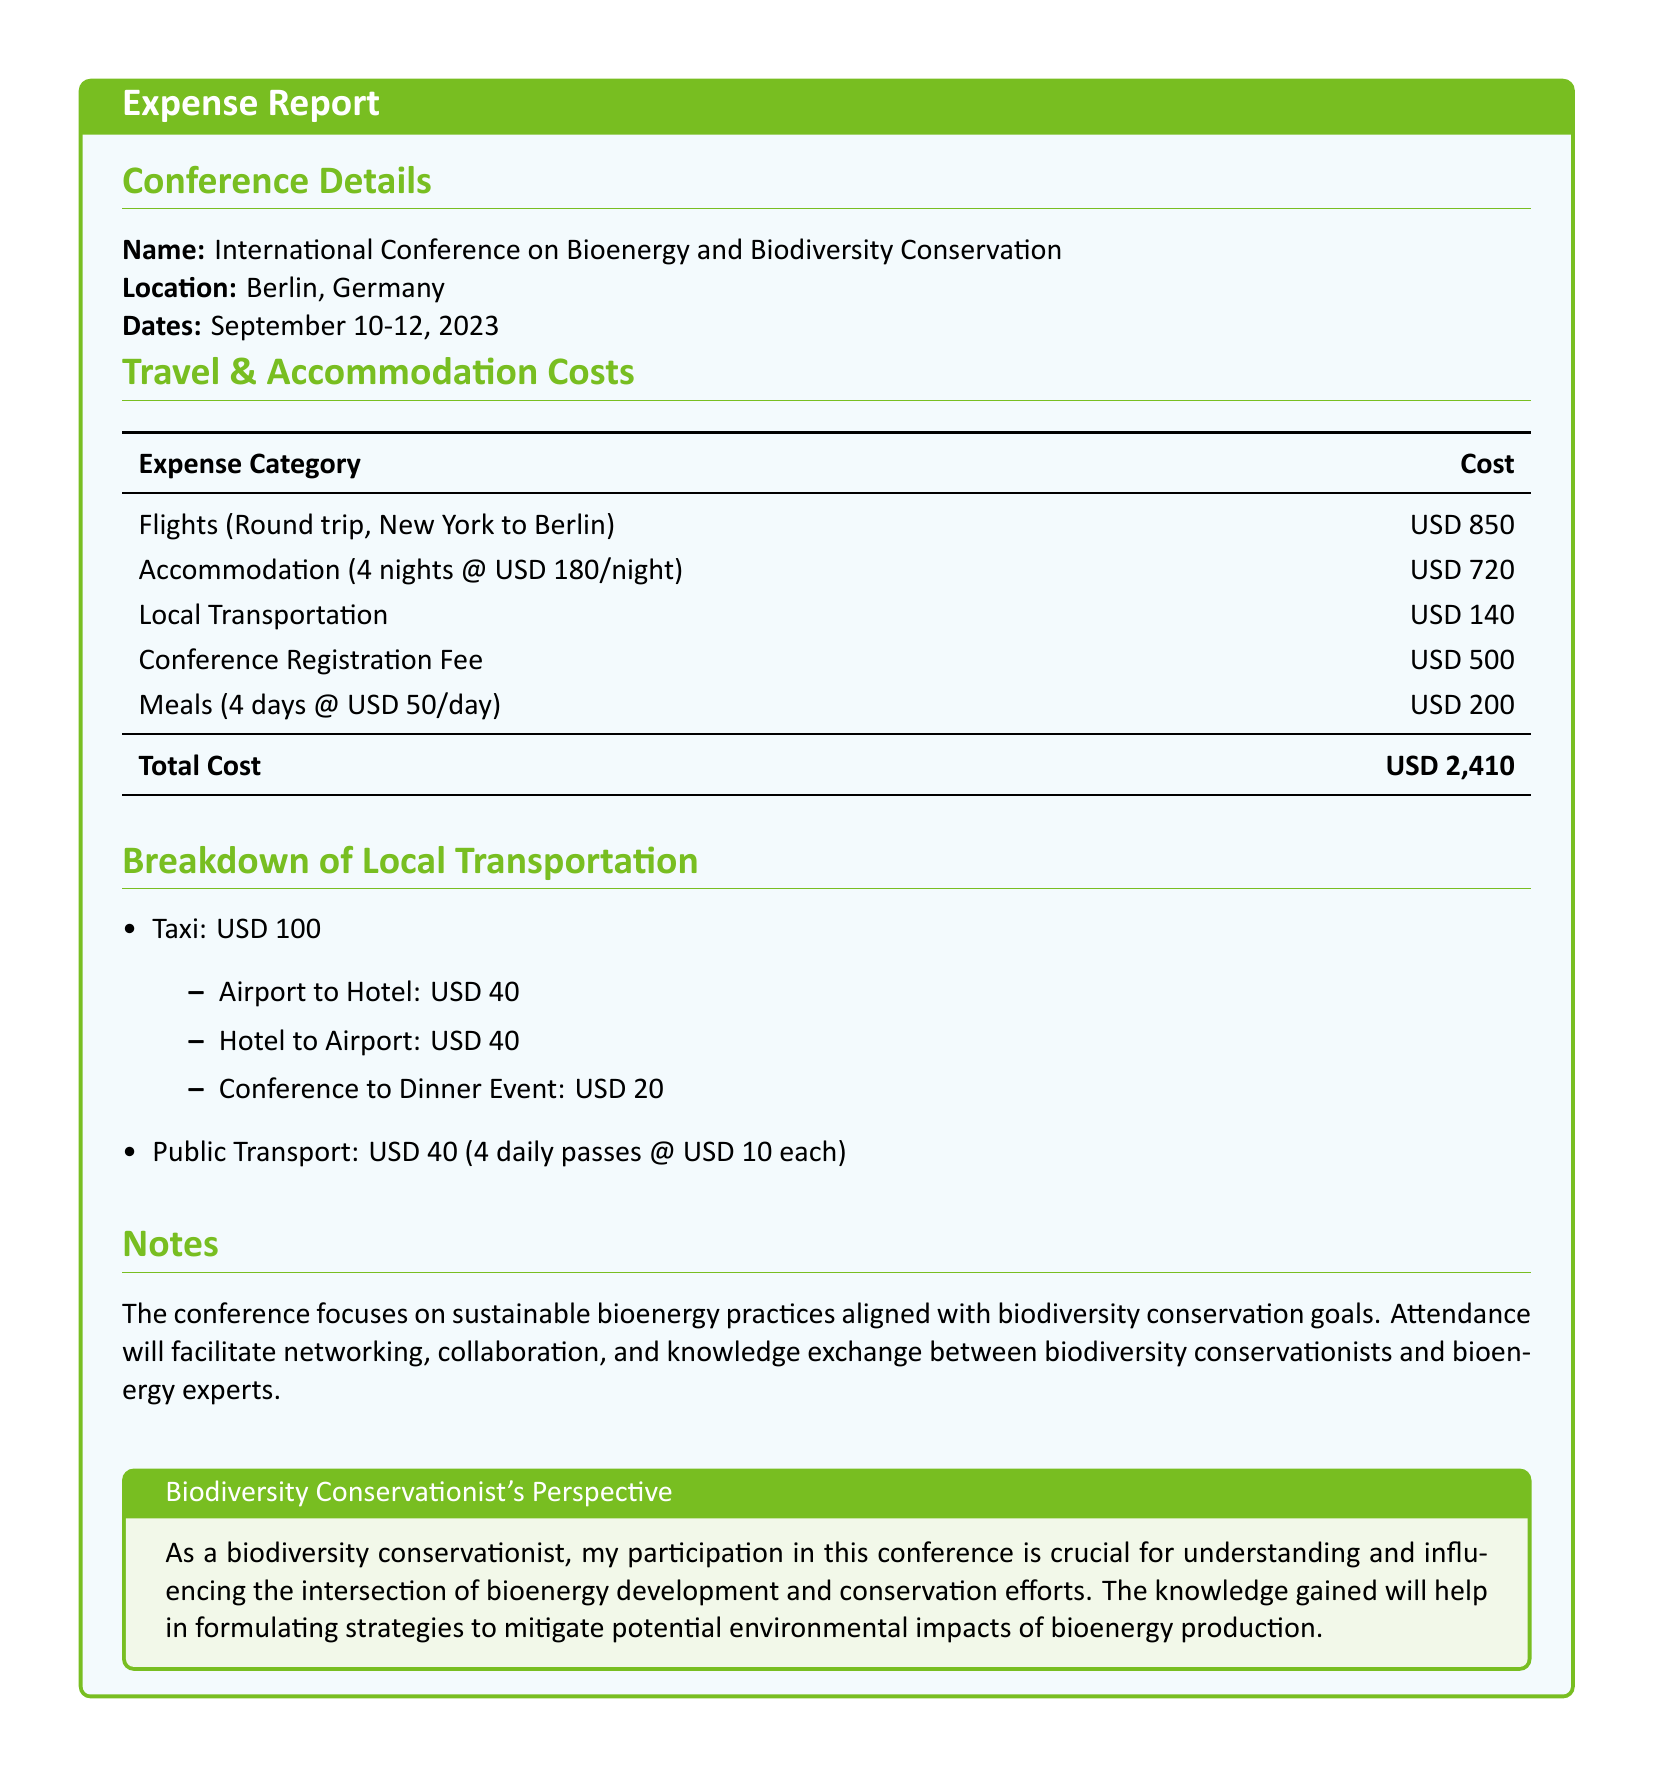What is the name of the conference? The name of the conference is mentioned in the document as "International Conference on Bioenergy and Biodiversity Conservation."
Answer: International Conference on Bioenergy and Biodiversity Conservation What is the total cost of travel and accommodation? The total cost is summarized in the expense table, which adds up all individual costs: Flights, Accommodation, Local Transportation, Conference Registration Fee, and Meals.
Answer: USD 2,410 How many nights of accommodation were booked? The document states that accommodation was for 4 nights at a specified rate.
Answer: 4 nights What was the cost of local transportation? The total cost for local transportation is explicitly stated in the travel and accommodation costs section.
Answer: USD 140 What was the registration fee for the conference? The fee for conference registration is clearly listed in the expense table.
Answer: USD 500 What percentage of the total cost is accounted for by accommodation? The accommodation cost can be compared to the total cost to calculate the percentage: (720 / 2410) * 100 = 29.9%.
Answer: 29.9% What type of notes are included in the report? The notes include observations on the conference's focus and its relevance to networking and knowledge exchange.
Answer: Sustainable bioenergy practices and biodiversity conservation goals What was the total cost for meals? The meals cost is specified in the expense section, detailing the daily rate multiplied by the number of days.
Answer: USD 200 What city hosted the conference? The location of the conference, as mentioned in the document, is Berlin, Germany.
Answer: Berlin, Germany 